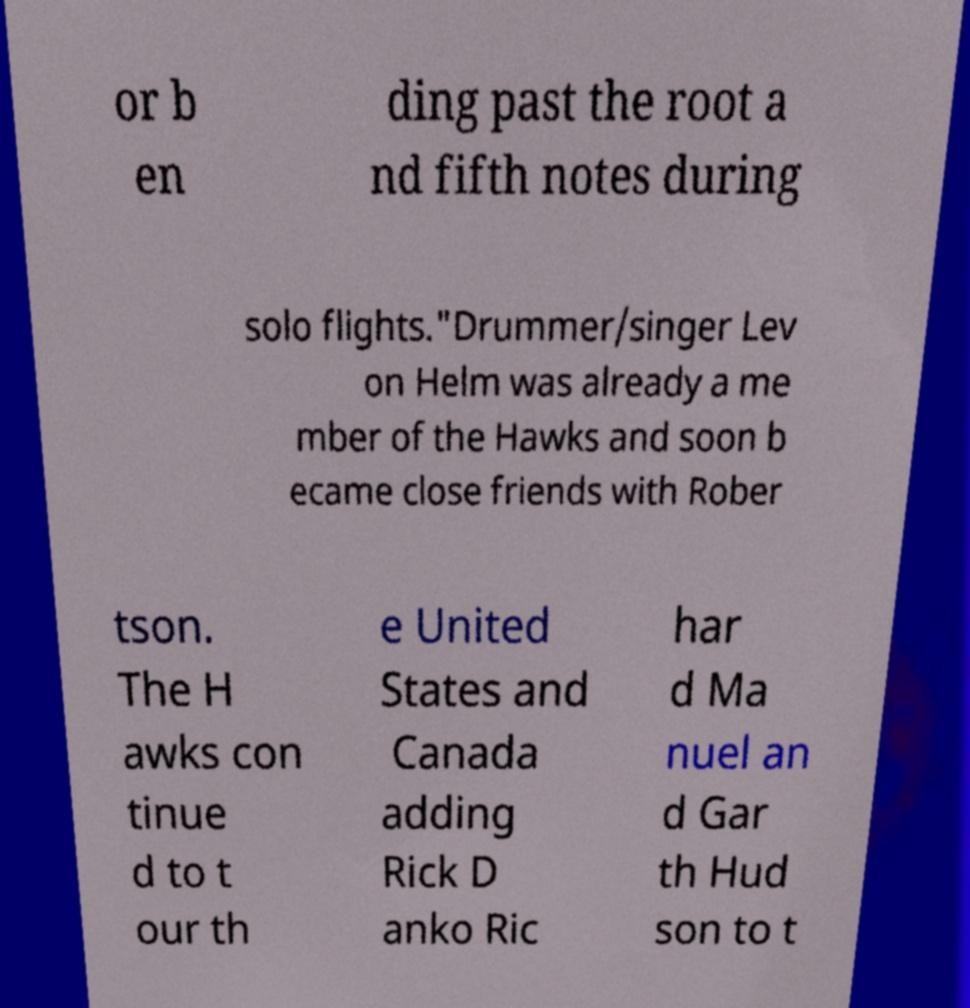Can you read and provide the text displayed in the image?This photo seems to have some interesting text. Can you extract and type it out for me? or b en ding past the root a nd fifth notes during solo flights."Drummer/singer Lev on Helm was already a me mber of the Hawks and soon b ecame close friends with Rober tson. The H awks con tinue d to t our th e United States and Canada adding Rick D anko Ric har d Ma nuel an d Gar th Hud son to t 